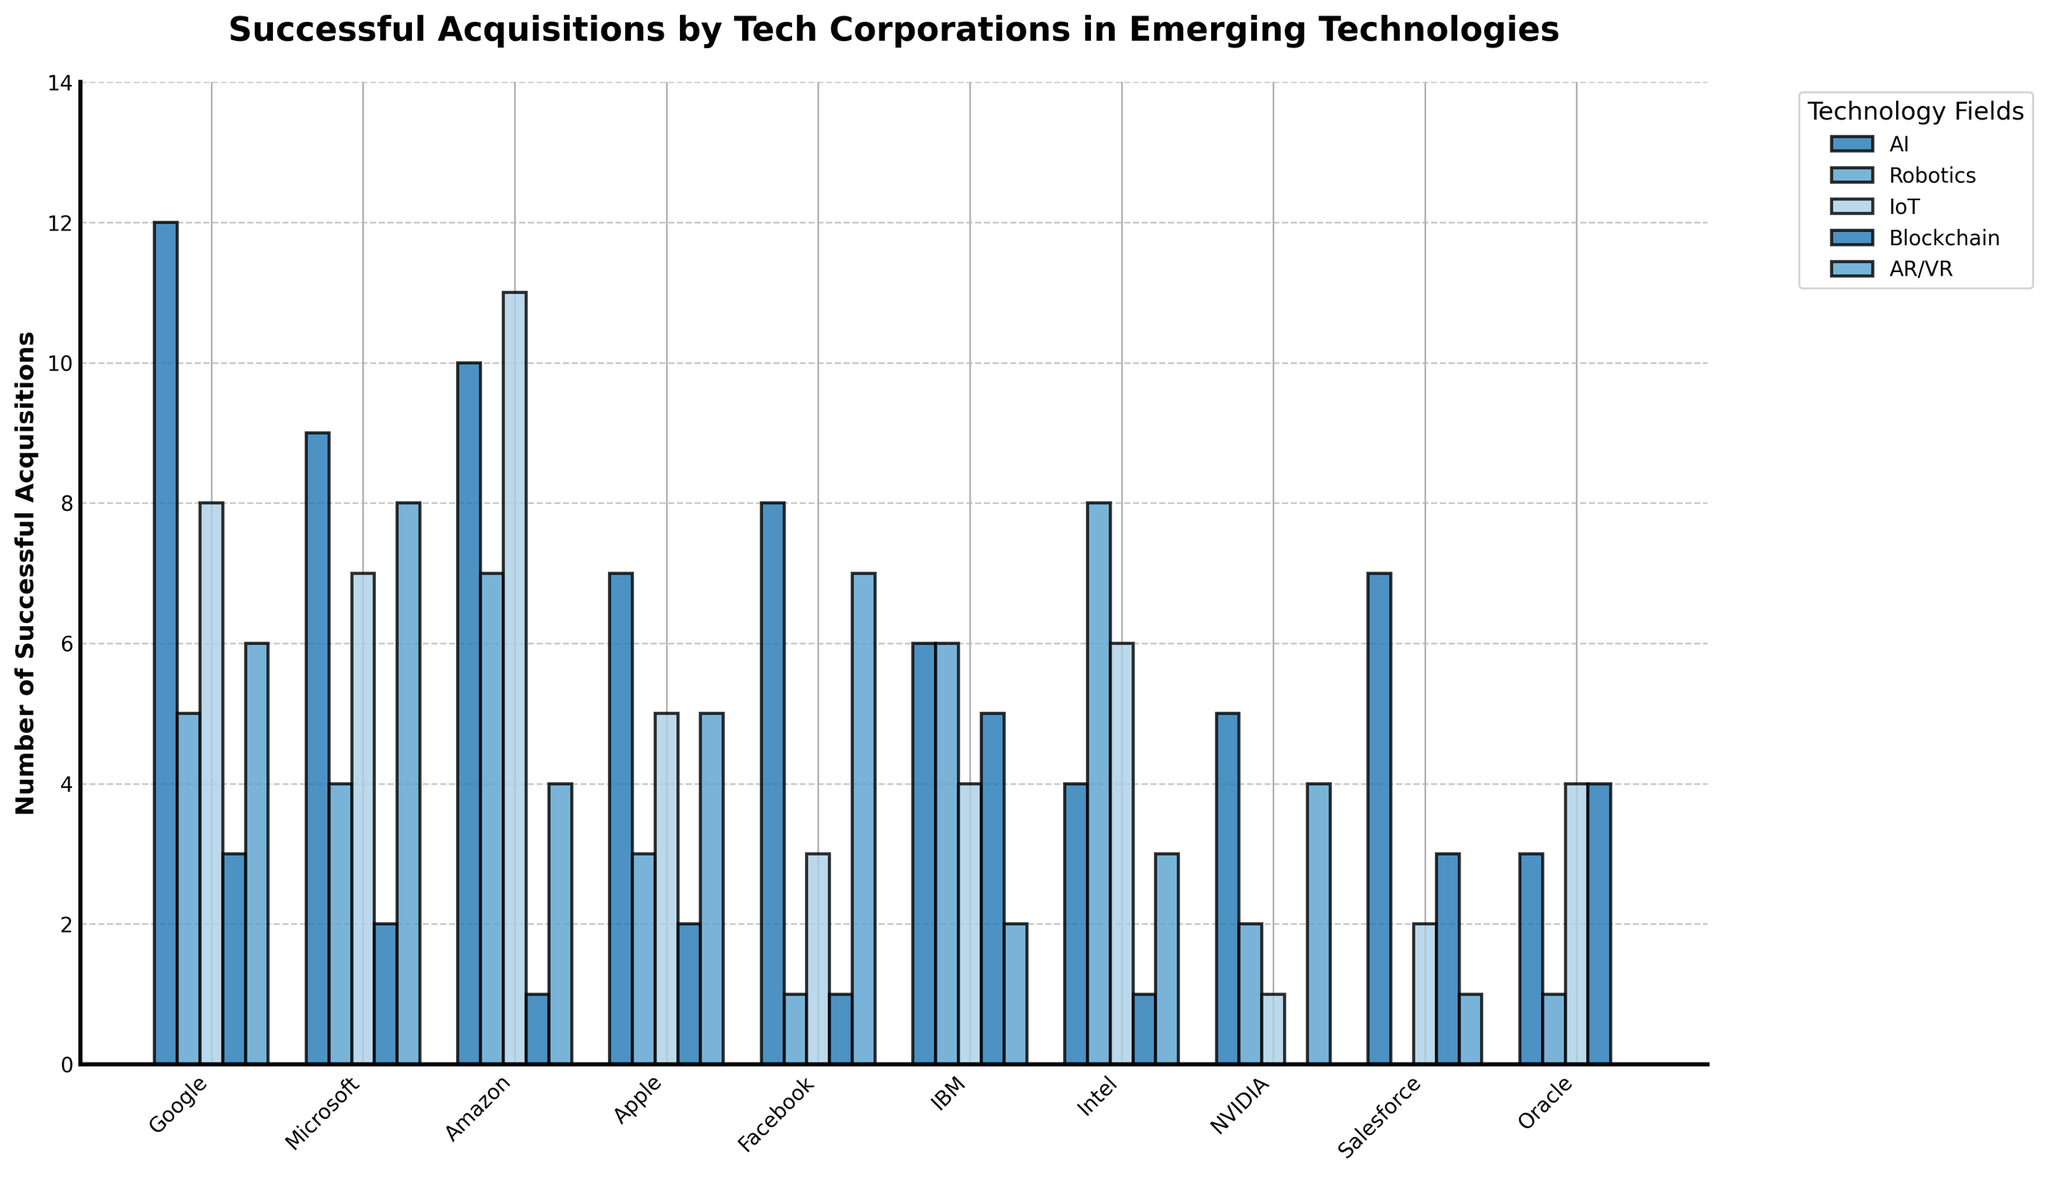How many successful acquisitions in AI did Facebook and Microsoft combine for? Facebook has 8 successful acquisitions and Microsoft has 9 in the AI category. Adding them together, 8 + 9 = 17
Answer: 17 Which company has the most successful acquisitions in IoT and how many are there? Amazon has the most successful acquisitions in IoT with 11
Answer: Amazon: 11 Which company has fewer successful acquisitions in Blockchain, NVIDIA or Amazon? NVIDIA has 0 successful acquisitions in Blockchain, and Amazon has 1
Answer: NVIDIA What is the overall trend of successful acquisitions in the AI category across all companies? The number of successful acquisitions in AI ranges from 3 (Oracle) to 12 (Google), with most companies having between 4 to 9 acquisitions, indicating a generally high interest in AI acquisitions
Answer: Generally high interest How many companies have exactly one successful acquisition in the AR/VR field? By examining the bar heights for the AR/VR field, Salesforce and Oracle each have 1 successful acquisition in AR/VR
Answer: 2 Who has more successful acquisitions in AR/VR, Google or Facebook? By comparing the heights of the bars, Google has 6 and Facebook has 7 in the AR/VR field
Answer: Facebook What's the difference in the number of successful acquisitions between Intel and IBM in the Robotics field? Intel has 8 acquisitions and IBM has 6 in Robotics. The difference is 8 - 6 = 2
Answer: 2 Which company is leading in successful acquisitions in the Blockchain field, and how many more does it have than the lowest in the same field? IBM is leading with 5, and NVIDIA has the lowest with 0. The difference is 5 - 0 = 5
Answer: IBM, 5 Calculate the average number of successful acquisitions in AI for Google and Apple. Google has 12 and Apple has 7 acquisitions in AI. The average is (12 + 7) / 2 = 9.5
Answer: 9.5 Which major technology field does Intel have the least number of successful acquisitions, and how many? In Blockchain, Intel has the least number of acquisitions with 1
Answer: Blockchain, 1 